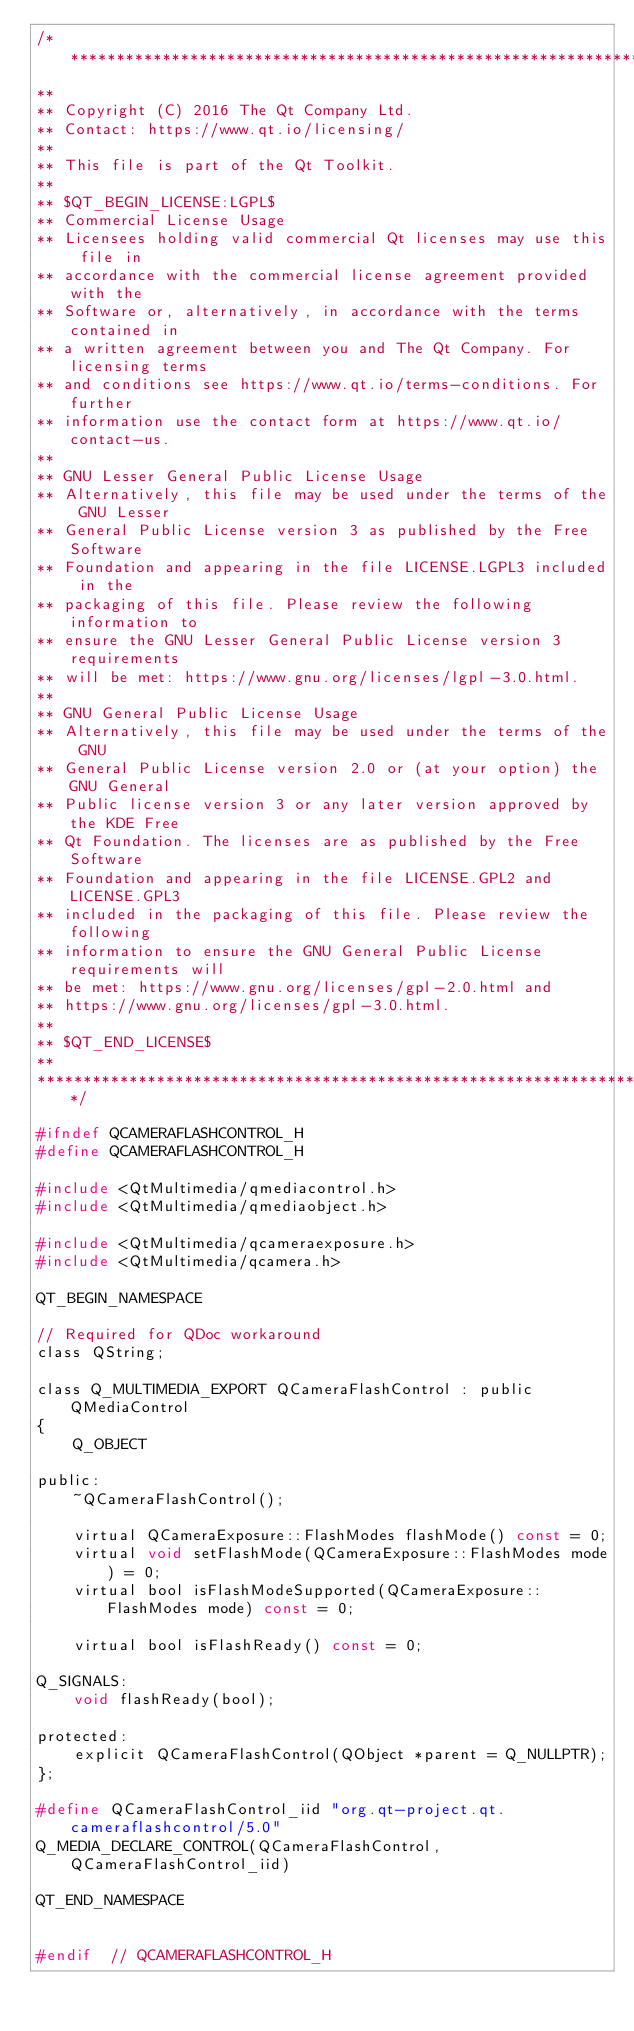<code> <loc_0><loc_0><loc_500><loc_500><_C_>/****************************************************************************
**
** Copyright (C) 2016 The Qt Company Ltd.
** Contact: https://www.qt.io/licensing/
**
** This file is part of the Qt Toolkit.
**
** $QT_BEGIN_LICENSE:LGPL$
** Commercial License Usage
** Licensees holding valid commercial Qt licenses may use this file in
** accordance with the commercial license agreement provided with the
** Software or, alternatively, in accordance with the terms contained in
** a written agreement between you and The Qt Company. For licensing terms
** and conditions see https://www.qt.io/terms-conditions. For further
** information use the contact form at https://www.qt.io/contact-us.
**
** GNU Lesser General Public License Usage
** Alternatively, this file may be used under the terms of the GNU Lesser
** General Public License version 3 as published by the Free Software
** Foundation and appearing in the file LICENSE.LGPL3 included in the
** packaging of this file. Please review the following information to
** ensure the GNU Lesser General Public License version 3 requirements
** will be met: https://www.gnu.org/licenses/lgpl-3.0.html.
**
** GNU General Public License Usage
** Alternatively, this file may be used under the terms of the GNU
** General Public License version 2.0 or (at your option) the GNU General
** Public license version 3 or any later version approved by the KDE Free
** Qt Foundation. The licenses are as published by the Free Software
** Foundation and appearing in the file LICENSE.GPL2 and LICENSE.GPL3
** included in the packaging of this file. Please review the following
** information to ensure the GNU General Public License requirements will
** be met: https://www.gnu.org/licenses/gpl-2.0.html and
** https://www.gnu.org/licenses/gpl-3.0.html.
**
** $QT_END_LICENSE$
**
****************************************************************************/

#ifndef QCAMERAFLASHCONTROL_H
#define QCAMERAFLASHCONTROL_H

#include <QtMultimedia/qmediacontrol.h>
#include <QtMultimedia/qmediaobject.h>

#include <QtMultimedia/qcameraexposure.h>
#include <QtMultimedia/qcamera.h>

QT_BEGIN_NAMESPACE

// Required for QDoc workaround
class QString;

class Q_MULTIMEDIA_EXPORT QCameraFlashControl : public QMediaControl
{
    Q_OBJECT

public:
    ~QCameraFlashControl();

    virtual QCameraExposure::FlashModes flashMode() const = 0;
    virtual void setFlashMode(QCameraExposure::FlashModes mode) = 0;
    virtual bool isFlashModeSupported(QCameraExposure::FlashModes mode) const = 0;

    virtual bool isFlashReady() const = 0;

Q_SIGNALS:
    void flashReady(bool);

protected:
    explicit QCameraFlashControl(QObject *parent = Q_NULLPTR);
};

#define QCameraFlashControl_iid "org.qt-project.qt.cameraflashcontrol/5.0"
Q_MEDIA_DECLARE_CONTROL(QCameraFlashControl, QCameraFlashControl_iid)

QT_END_NAMESPACE


#endif  // QCAMERAFLASHCONTROL_H

</code> 